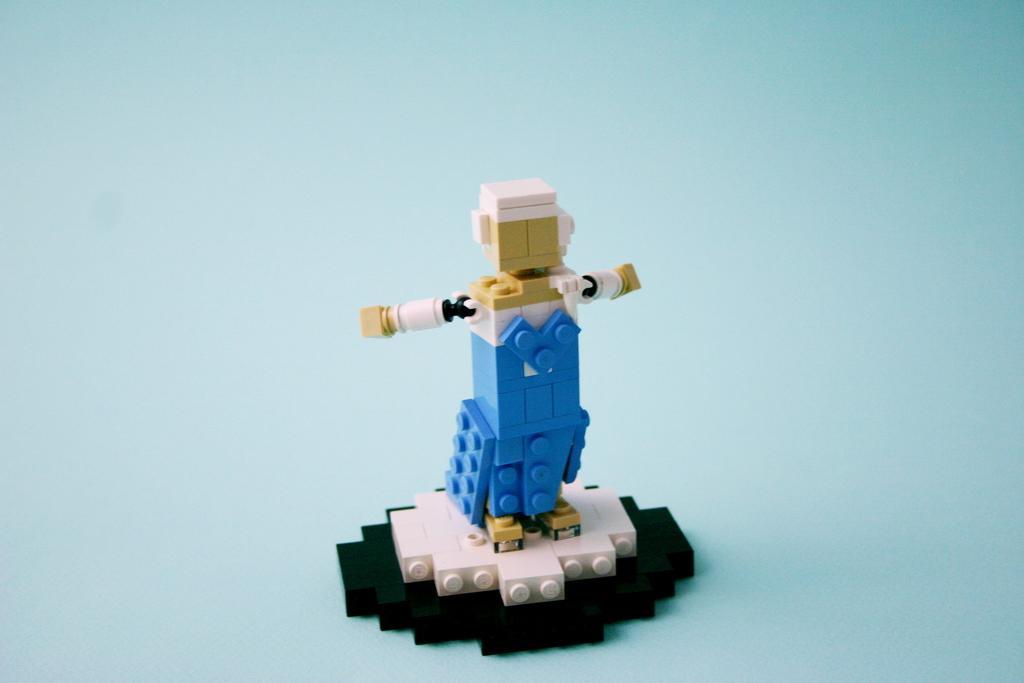What object can be seen in the image? There is a toy in the image. What is the color of the surface on which the toy is placed? The toy is on a blue surface. What is the level of wealth depicted in the image? There is no indication of wealth in the image, as it only features a toy on a blue surface. 